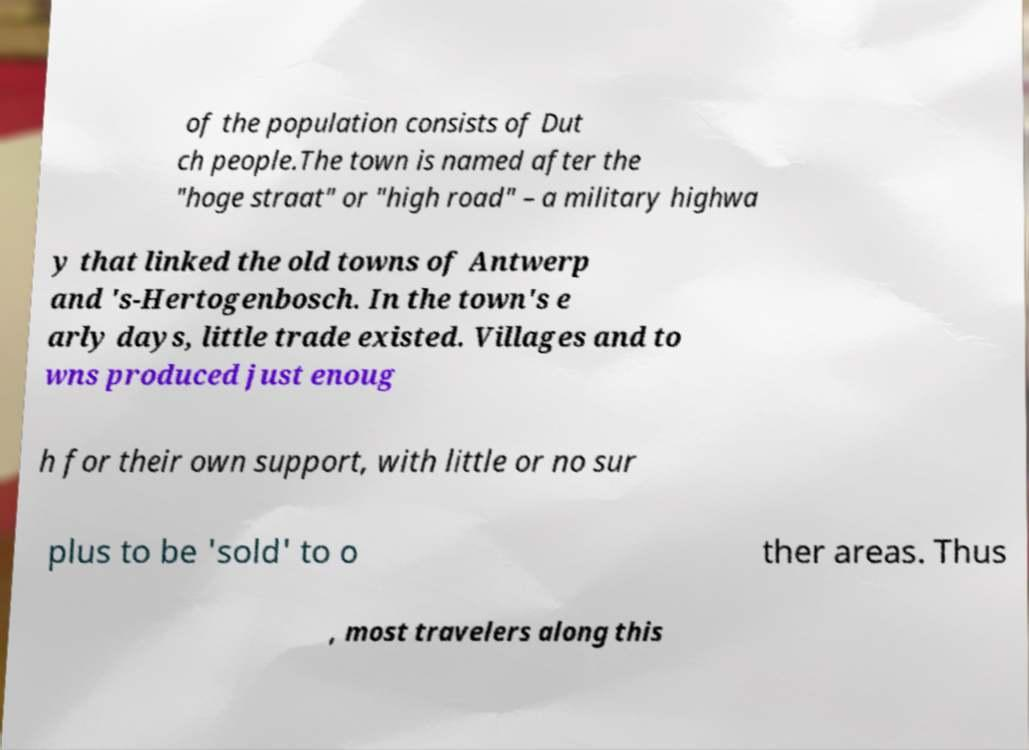Please read and relay the text visible in this image. What does it say? of the population consists of Dut ch people.The town is named after the "hoge straat" or "high road" – a military highwa y that linked the old towns of Antwerp and 's-Hertogenbosch. In the town's e arly days, little trade existed. Villages and to wns produced just enoug h for their own support, with little or no sur plus to be 'sold' to o ther areas. Thus , most travelers along this 